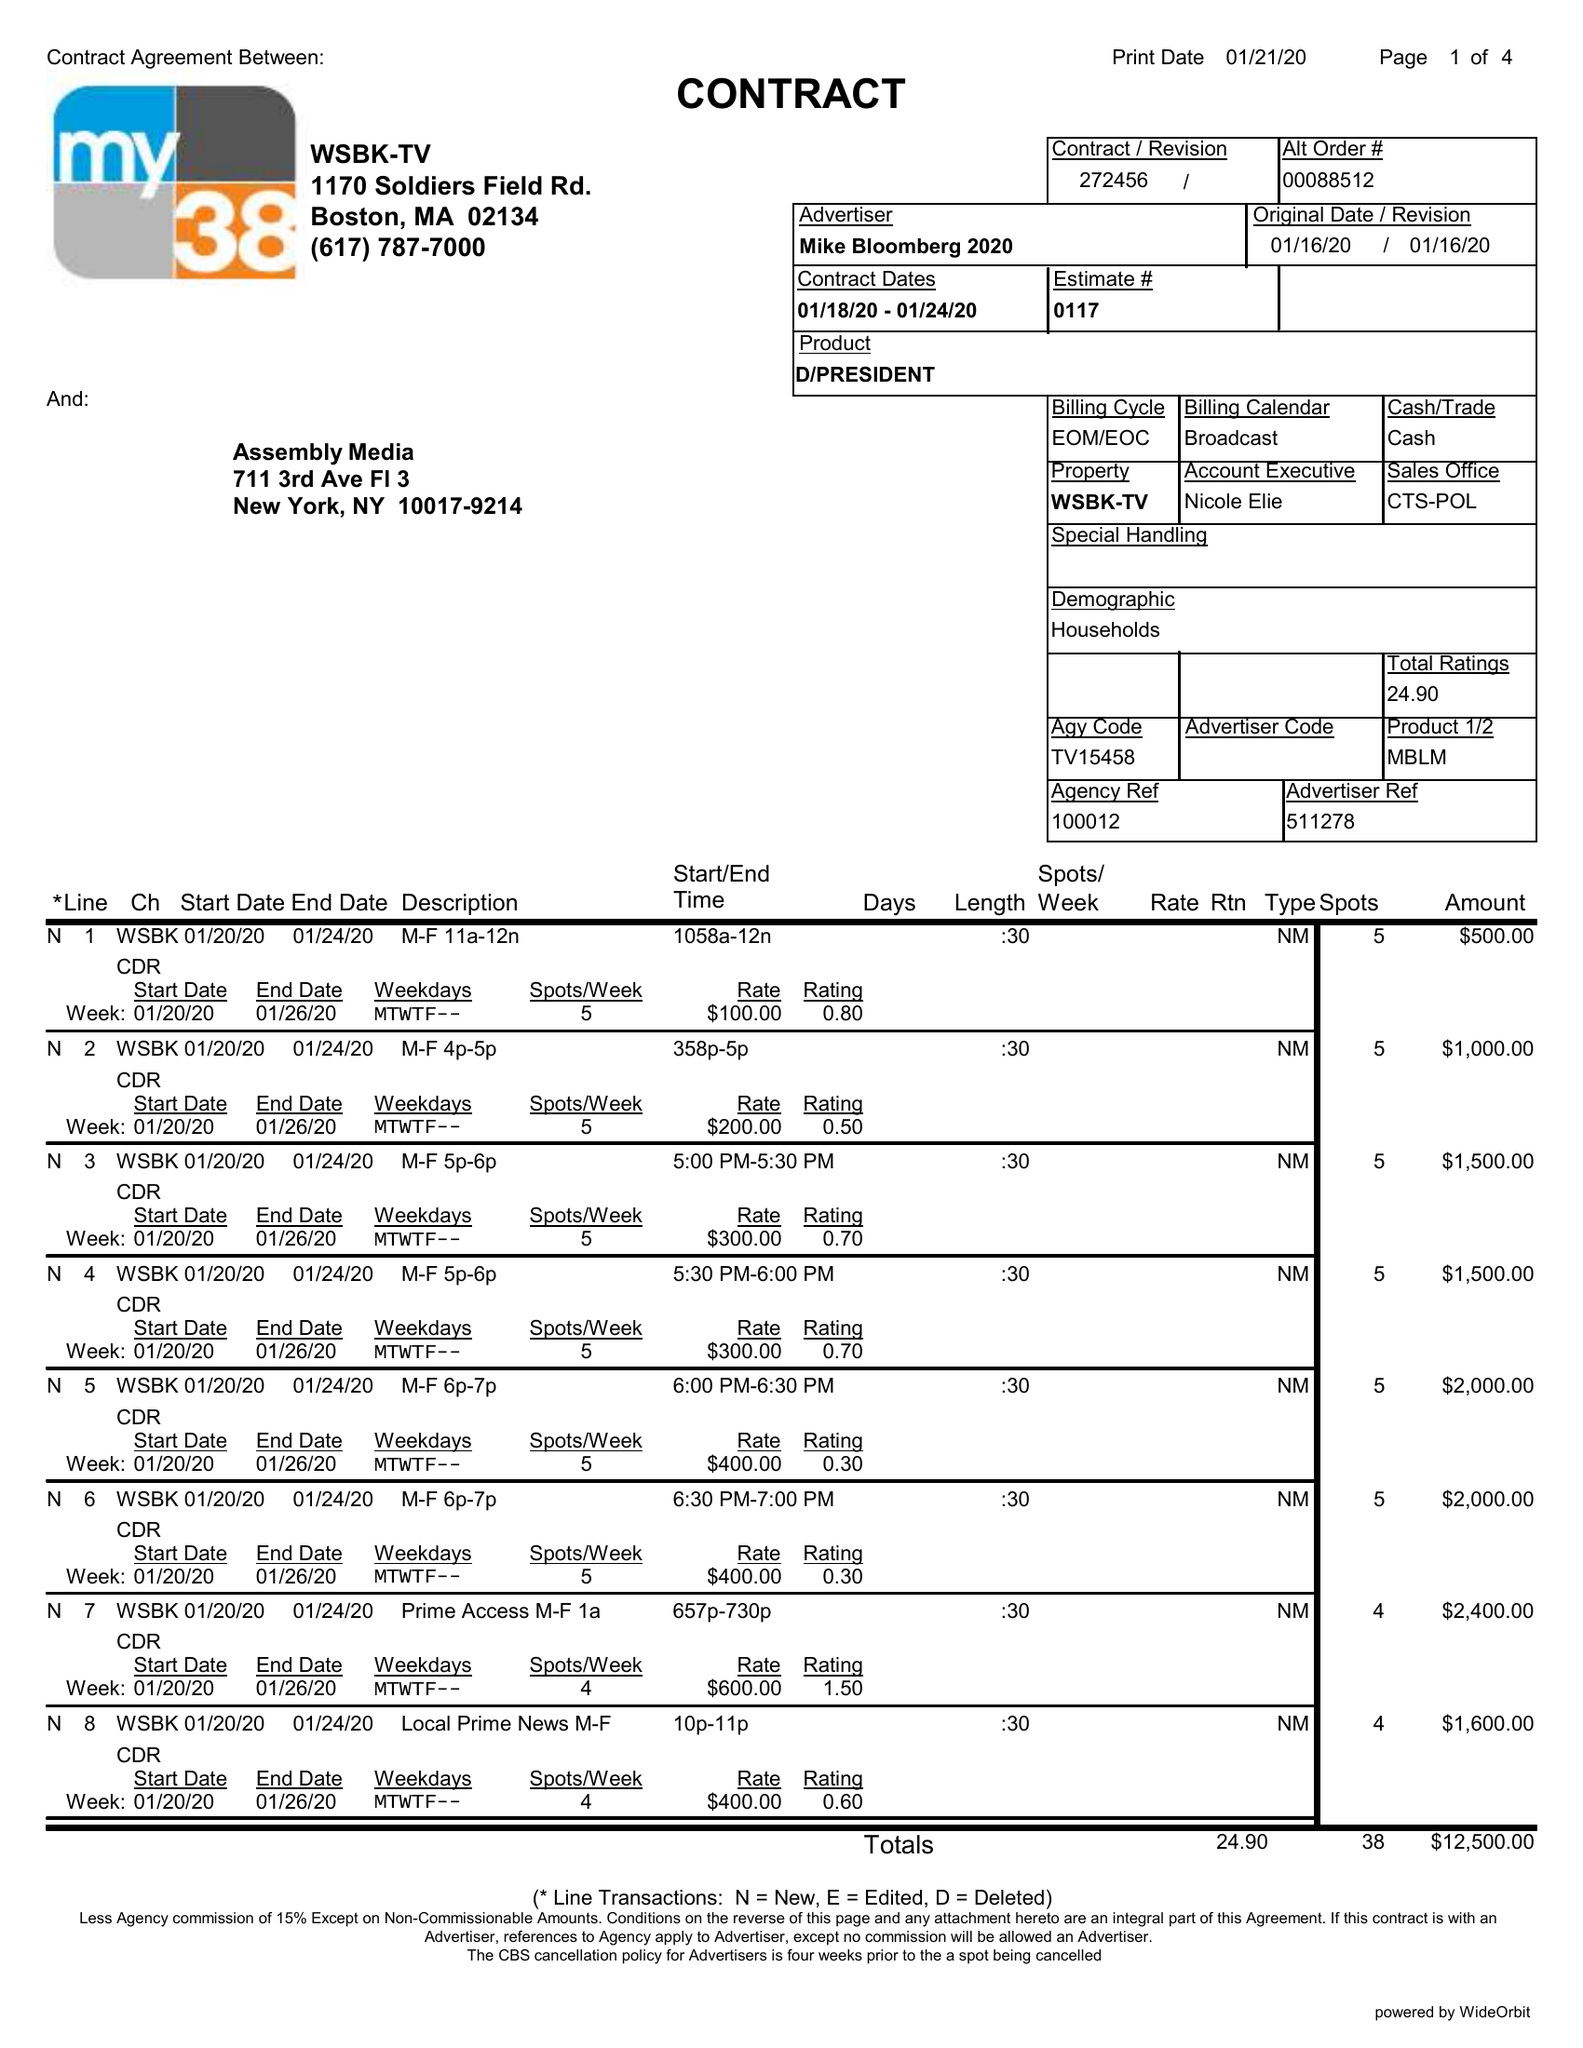What is the value for the flight_to?
Answer the question using a single word or phrase. 01/24/20 